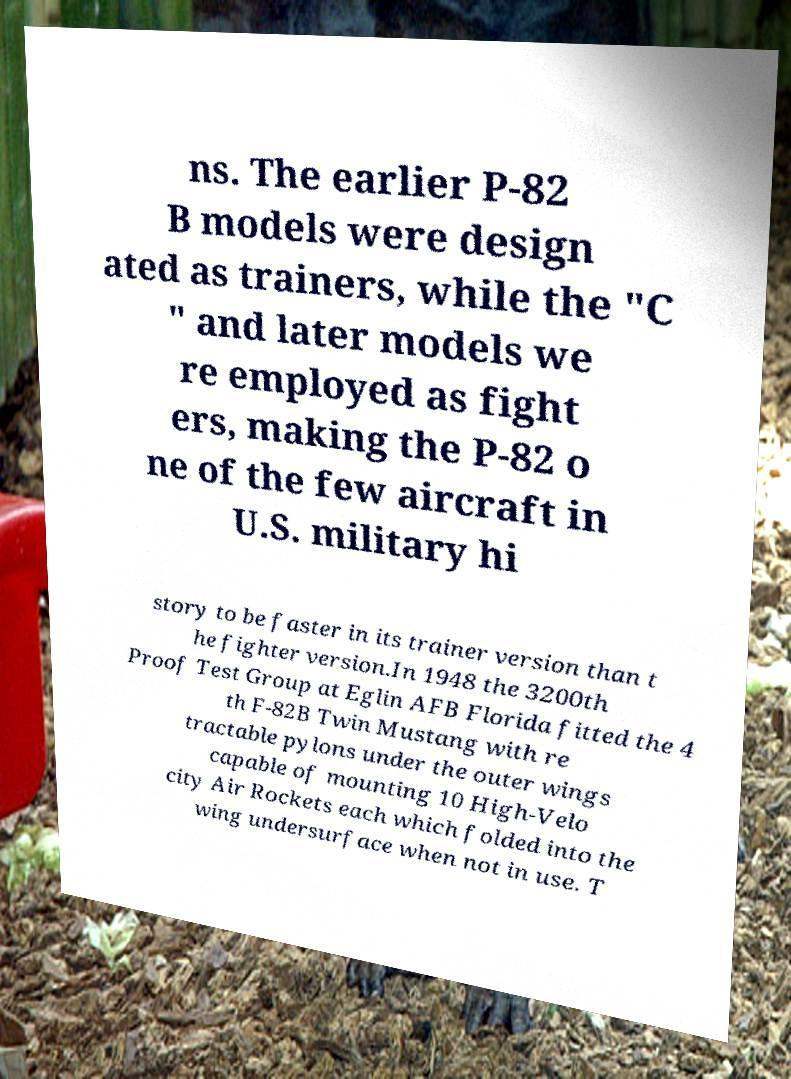Can you read and provide the text displayed in the image?This photo seems to have some interesting text. Can you extract and type it out for me? ns. The earlier P-82 B models were design ated as trainers, while the "C " and later models we re employed as fight ers, making the P-82 o ne of the few aircraft in U.S. military hi story to be faster in its trainer version than t he fighter version.In 1948 the 3200th Proof Test Group at Eglin AFB Florida fitted the 4 th F-82B Twin Mustang with re tractable pylons under the outer wings capable of mounting 10 High-Velo city Air Rockets each which folded into the wing undersurface when not in use. T 